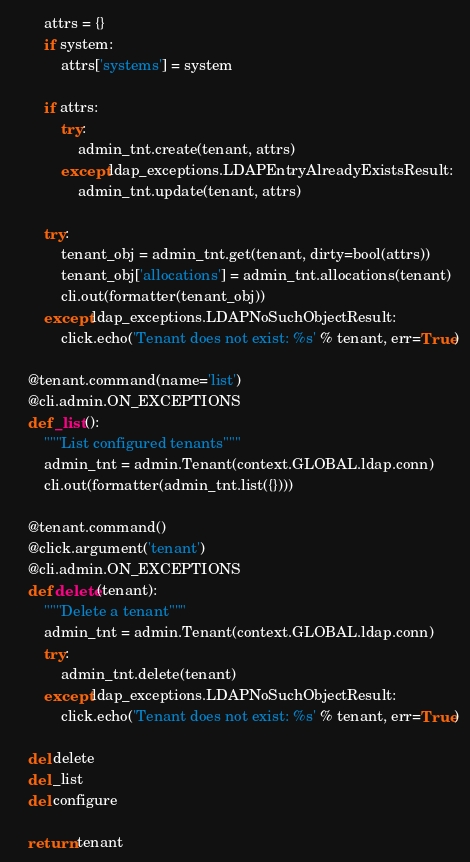Convert code to text. <code><loc_0><loc_0><loc_500><loc_500><_Python_>        attrs = {}
        if system:
            attrs['systems'] = system

        if attrs:
            try:
                admin_tnt.create(tenant, attrs)
            except ldap_exceptions.LDAPEntryAlreadyExistsResult:
                admin_tnt.update(tenant, attrs)

        try:
            tenant_obj = admin_tnt.get(tenant, dirty=bool(attrs))
            tenant_obj['allocations'] = admin_tnt.allocations(tenant)
            cli.out(formatter(tenant_obj))
        except ldap_exceptions.LDAPNoSuchObjectResult:
            click.echo('Tenant does not exist: %s' % tenant, err=True)

    @tenant.command(name='list')
    @cli.admin.ON_EXCEPTIONS
    def _list():
        """List configured tenants"""
        admin_tnt = admin.Tenant(context.GLOBAL.ldap.conn)
        cli.out(formatter(admin_tnt.list({})))

    @tenant.command()
    @click.argument('tenant')
    @cli.admin.ON_EXCEPTIONS
    def delete(tenant):
        """Delete a tenant"""
        admin_tnt = admin.Tenant(context.GLOBAL.ldap.conn)
        try:
            admin_tnt.delete(tenant)
        except ldap_exceptions.LDAPNoSuchObjectResult:
            click.echo('Tenant does not exist: %s' % tenant, err=True)

    del delete
    del _list
    del configure

    return tenant
</code> 